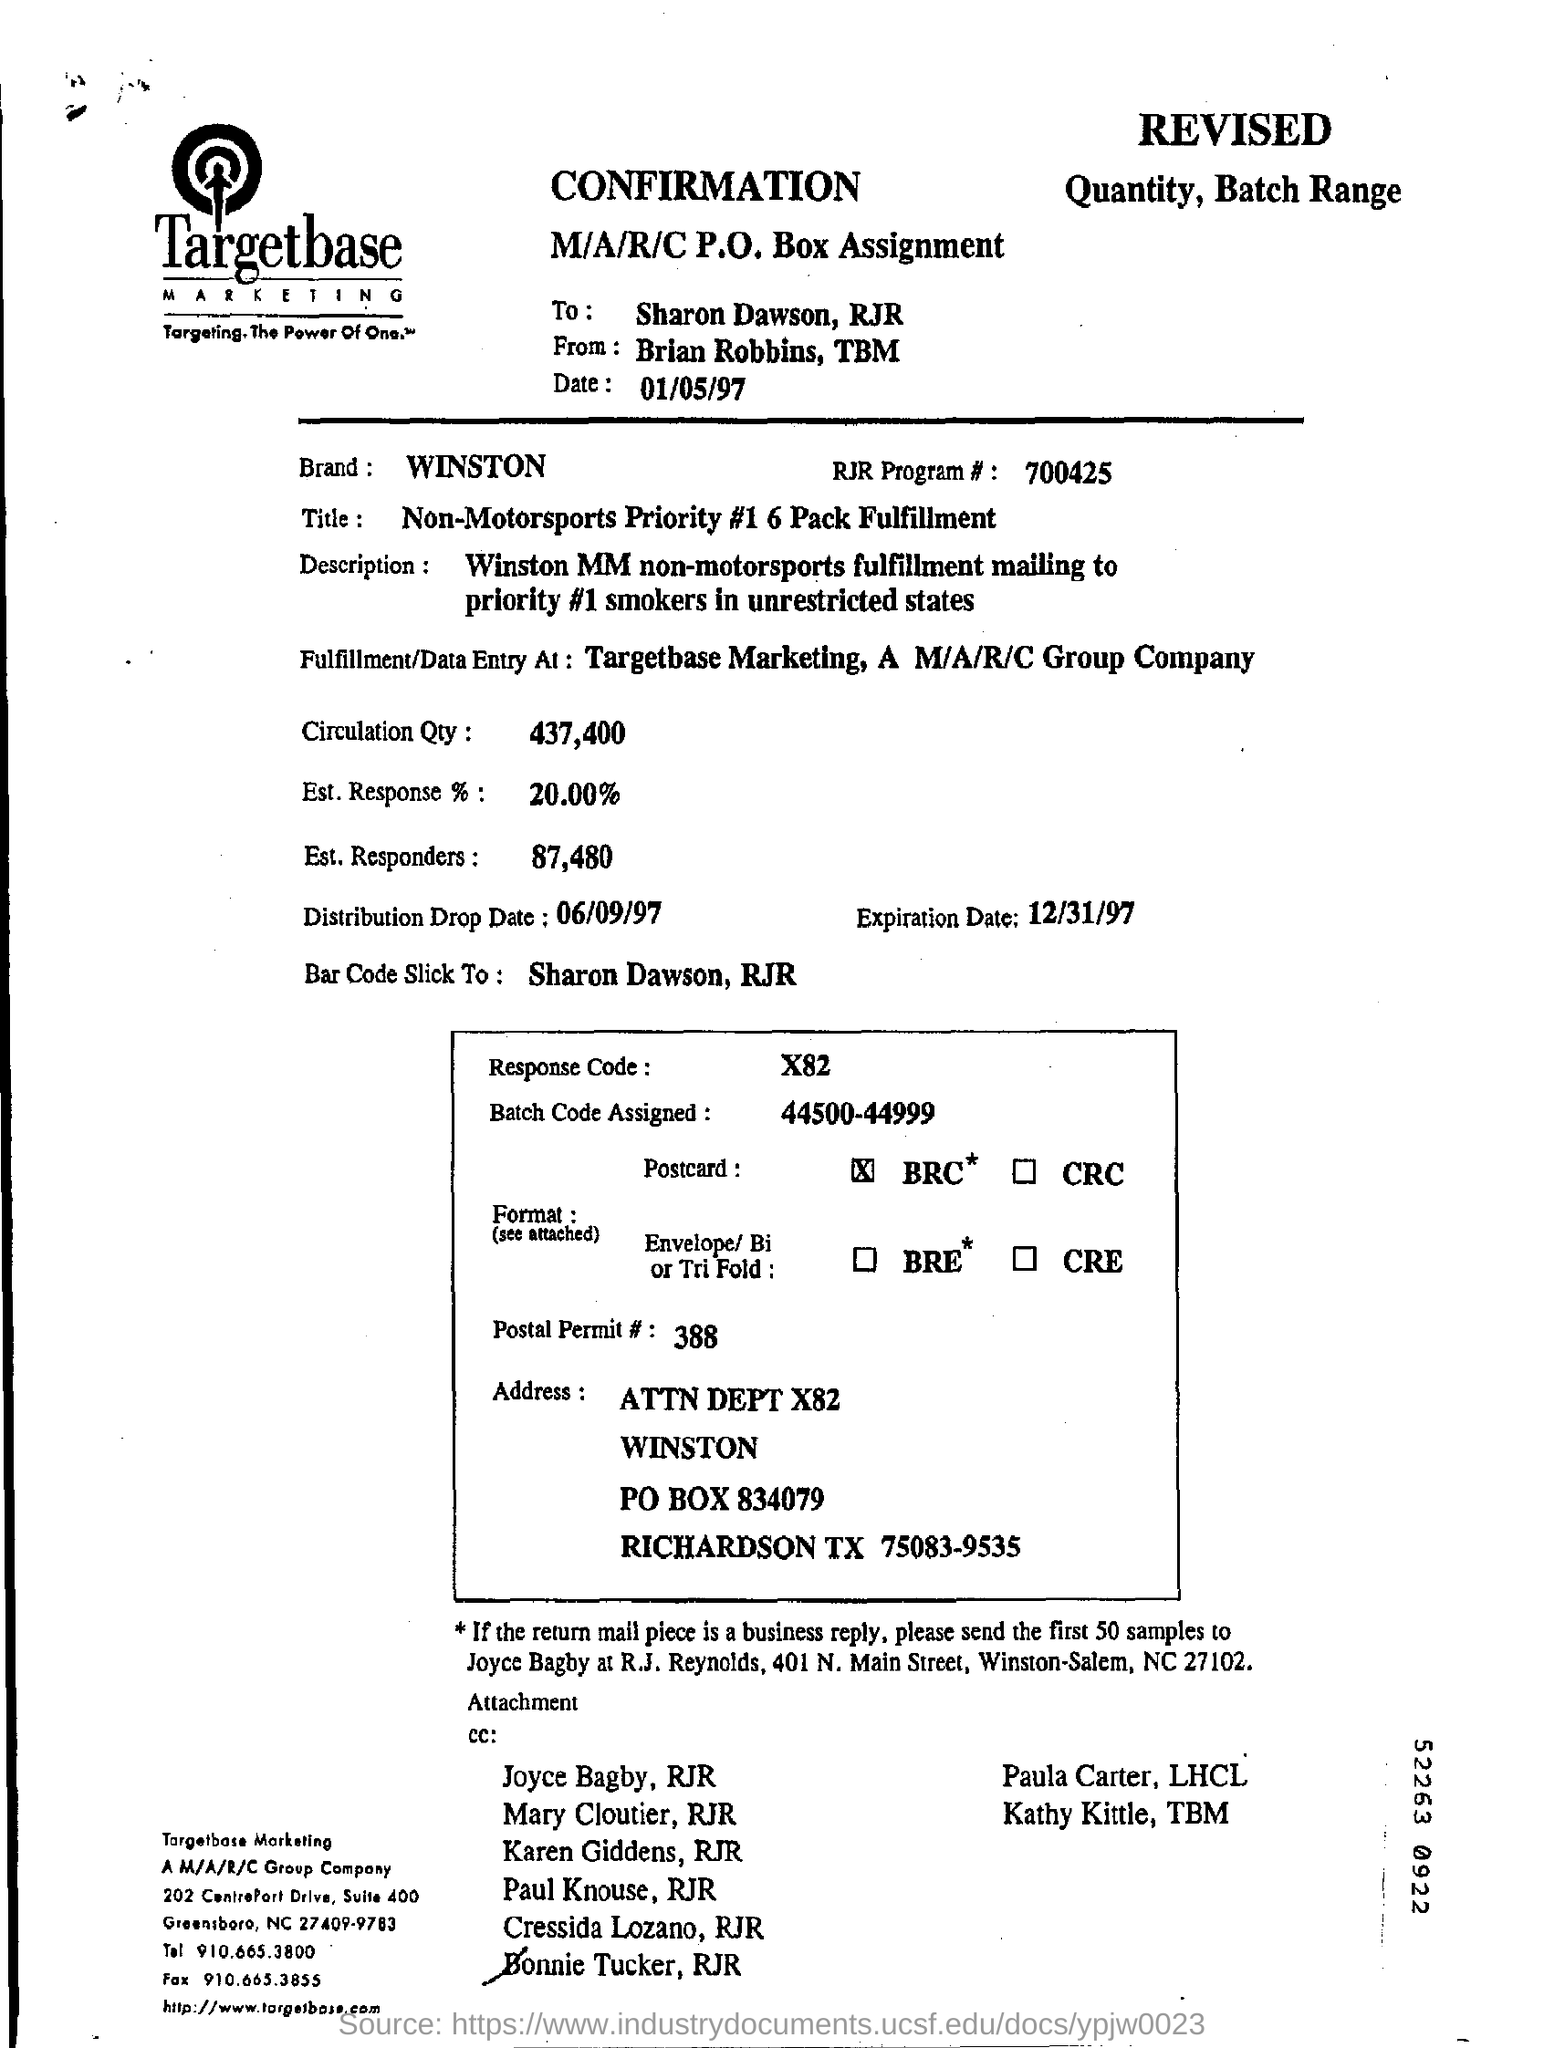Draw attention to some important aspects in this diagram. Targetbase Marketing is the company whose name is located at the top of the page. The expiration date is December 31, 1997. The RJR Program number is 700425, as stated. Targetbase Marketing's tagline is "Targeting. The Power of One. TM." which emphasizes the company's focus on using data-driven targeting strategies to drive business results for its clients. The estimated response is 20.00%. 